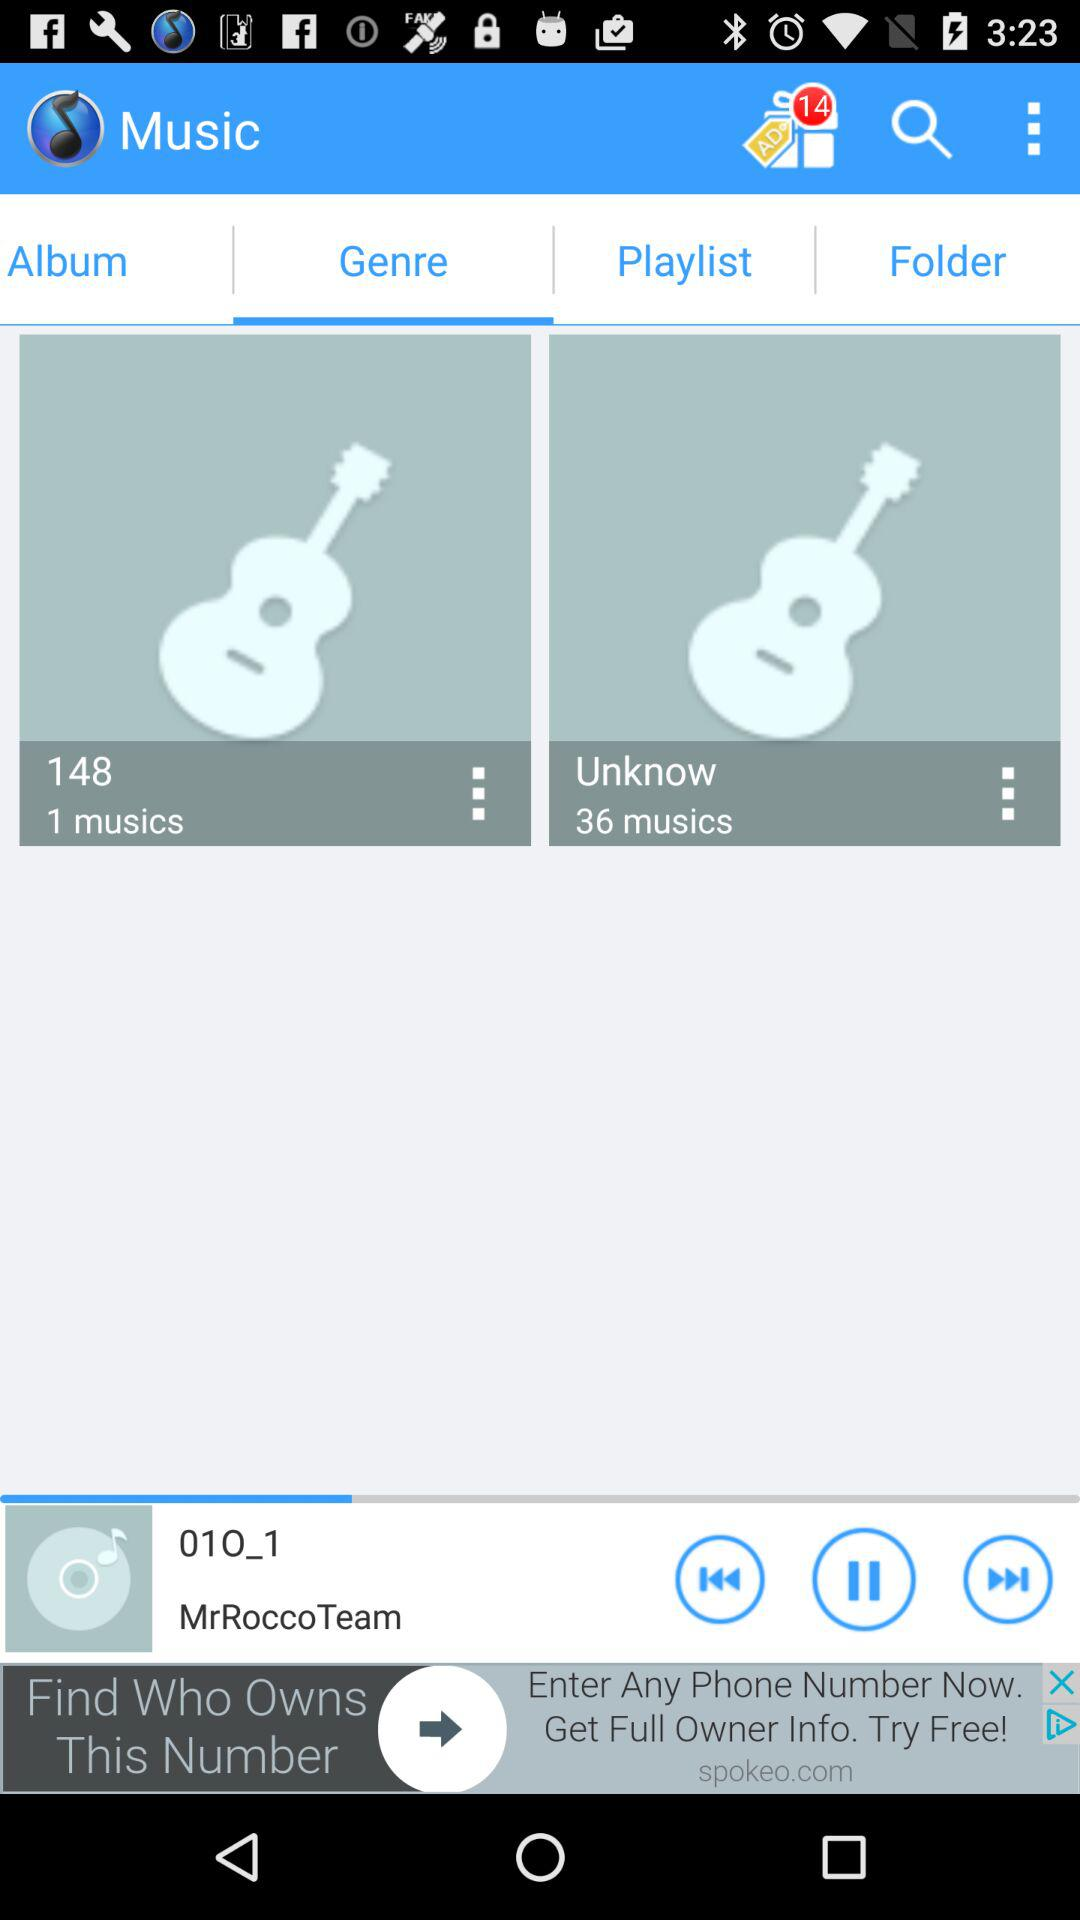Which song is playing? The song that is playing is "01O_1". 